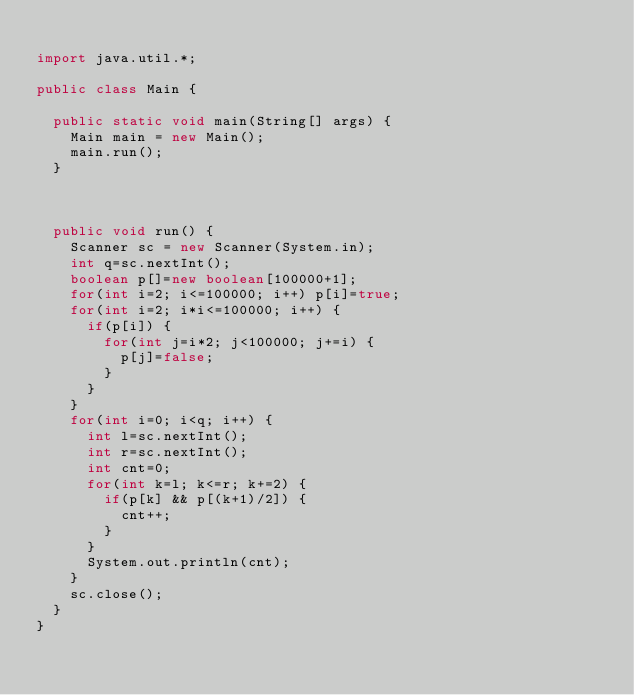Convert code to text. <code><loc_0><loc_0><loc_500><loc_500><_Java_>
import java.util.*;

public class Main {

	public static void main(String[] args) {
		Main main = new Main();
		main.run();
	}



	public void run() {
		Scanner sc = new Scanner(System.in);
		int q=sc.nextInt();
		boolean p[]=new boolean[100000+1];
		for(int i=2; i<=100000; i++) p[i]=true;
		for(int i=2; i*i<=100000; i++) {
			if(p[i]) {
				for(int j=i*2; j<100000; j+=i) {
					p[j]=false;
				}
			}
		}
		for(int i=0; i<q; i++) {
			int l=sc.nextInt();
			int r=sc.nextInt();
			int cnt=0;
			for(int k=l; k<=r; k+=2) {
				if(p[k] && p[(k+1)/2]) {
					cnt++;
				}
			}
			System.out.println(cnt);
		}
		sc.close();
	}
}
</code> 